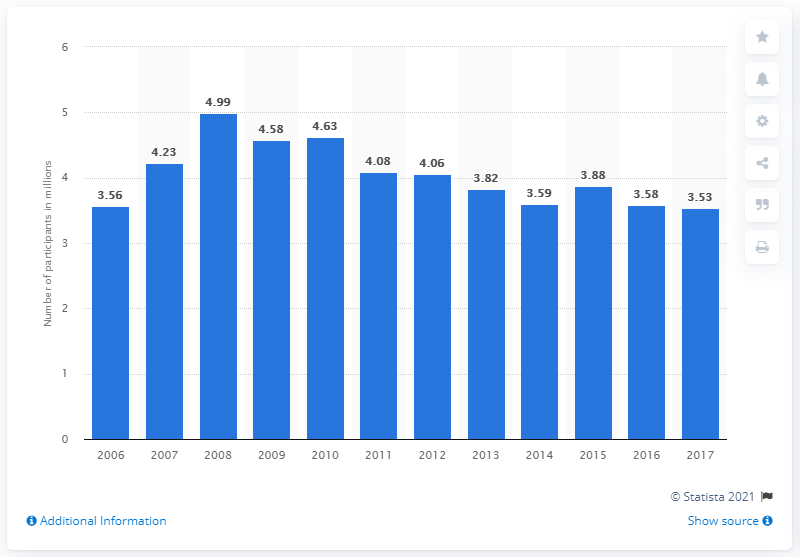Highlight a few significant elements in this photo. In 2017, the total number of participants in racquetball was 3.53 million. 